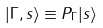<formula> <loc_0><loc_0><loc_500><loc_500>| \Gamma , s \rangle \equiv P _ { \Gamma } | s \rangle</formula> 